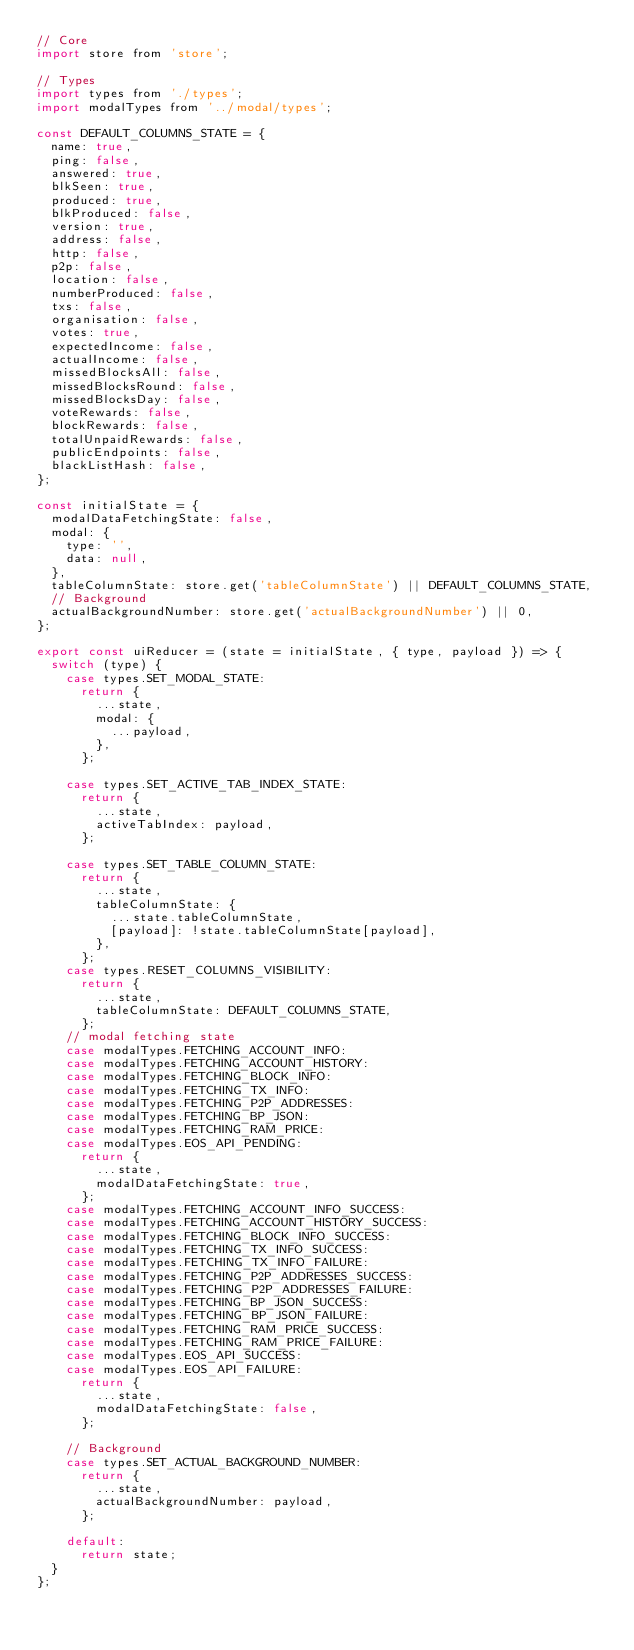<code> <loc_0><loc_0><loc_500><loc_500><_JavaScript_>// Core
import store from 'store';

// Types
import types from './types';
import modalTypes from '../modal/types';

const DEFAULT_COLUMNS_STATE = {
  name: true,
  ping: false,
  answered: true,
  blkSeen: true,
  produced: true,
  blkProduced: false,
  version: true,
  address: false,
  http: false,
  p2p: false,
  location: false,
  numberProduced: false,
  txs: false,
  organisation: false,
  votes: true,
  expectedIncome: false,
  actualIncome: false,
  missedBlocksAll: false,
  missedBlocksRound: false,
  missedBlocksDay: false,
  voteRewards: false,
  blockRewards: false,
  totalUnpaidRewards: false,
  publicEndpoints: false,
  blackListHash: false,
};

const initialState = {
  modalDataFetchingState: false,
  modal: {
    type: '',
    data: null,
  },
  tableColumnState: store.get('tableColumnState') || DEFAULT_COLUMNS_STATE,
  // Background
  actualBackgroundNumber: store.get('actualBackgroundNumber') || 0,
};

export const uiReducer = (state = initialState, { type, payload }) => {
  switch (type) {
    case types.SET_MODAL_STATE:
      return {
        ...state,
        modal: {
          ...payload,
        },
      };

    case types.SET_ACTIVE_TAB_INDEX_STATE:
      return {
        ...state,
        activeTabIndex: payload,
      };

    case types.SET_TABLE_COLUMN_STATE:
      return {
        ...state,
        tableColumnState: {
          ...state.tableColumnState,
          [payload]: !state.tableColumnState[payload],
        },
      };
    case types.RESET_COLUMNS_VISIBILITY:
      return {
        ...state,
        tableColumnState: DEFAULT_COLUMNS_STATE,
      };
    // modal fetching state
    case modalTypes.FETCHING_ACCOUNT_INFO:
    case modalTypes.FETCHING_ACCOUNT_HISTORY:
    case modalTypes.FETCHING_BLOCK_INFO:
    case modalTypes.FETCHING_TX_INFO:
    case modalTypes.FETCHING_P2P_ADDRESSES:
    case modalTypes.FETCHING_BP_JSON:
    case modalTypes.FETCHING_RAM_PRICE:
    case modalTypes.EOS_API_PENDING:
      return {
        ...state,
        modalDataFetchingState: true,
      };
    case modalTypes.FETCHING_ACCOUNT_INFO_SUCCESS:
    case modalTypes.FETCHING_ACCOUNT_HISTORY_SUCCESS:
    case modalTypes.FETCHING_BLOCK_INFO_SUCCESS:
    case modalTypes.FETCHING_TX_INFO_SUCCESS:
    case modalTypes.FETCHING_TX_INFO_FAILURE:
    case modalTypes.FETCHING_P2P_ADDRESSES_SUCCESS:
    case modalTypes.FETCHING_P2P_ADDRESSES_FAILURE:
    case modalTypes.FETCHING_BP_JSON_SUCCESS:
    case modalTypes.FETCHING_BP_JSON_FAILURE:
    case modalTypes.FETCHING_RAM_PRICE_SUCCESS:
    case modalTypes.FETCHING_RAM_PRICE_FAILURE:
    case modalTypes.EOS_API_SUCCESS:
    case modalTypes.EOS_API_FAILURE:
      return {
        ...state,
        modalDataFetchingState: false,
      };

    // Background
    case types.SET_ACTUAL_BACKGROUND_NUMBER:
      return {
        ...state,
        actualBackgroundNumber: payload,
      };

    default:
      return state;
  }
};
</code> 